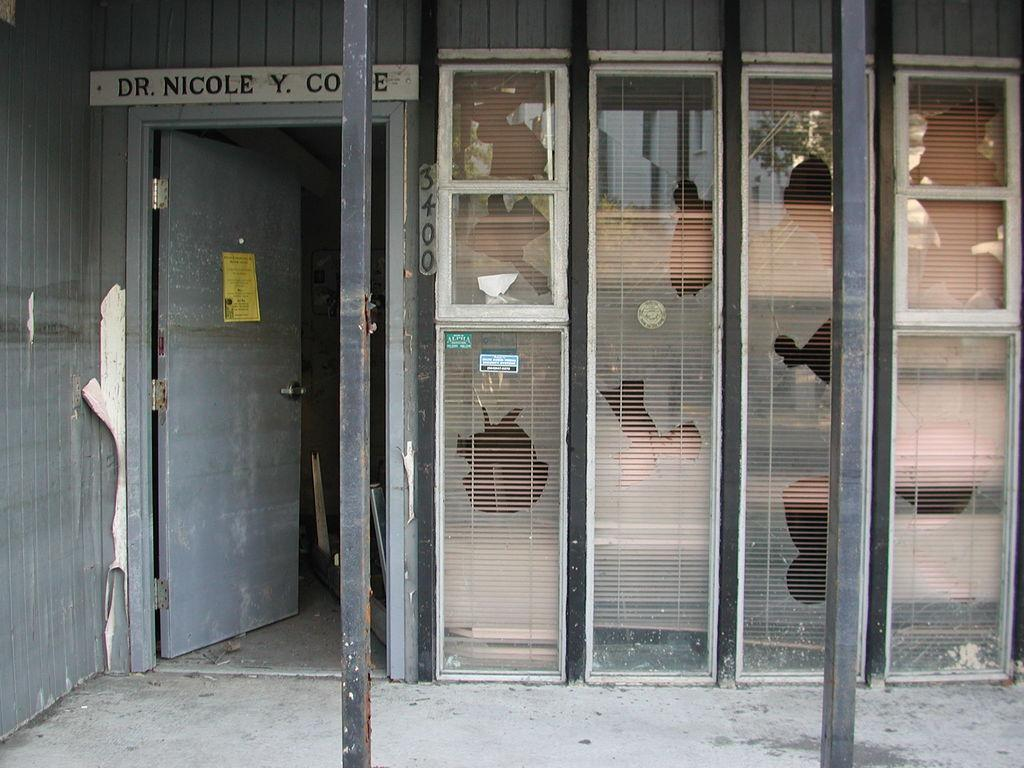What objects can be seen in the image? There are two wooden poles in the image. What can be seen in the background of the image? There is a door in the background of the image, and it is gray in color. Additionally, there are glass doors visible in the background. What type of hill can be seen in the image? There is no hill present in the image; it only features two wooden poles, a gray door, and glass doors in the background. 